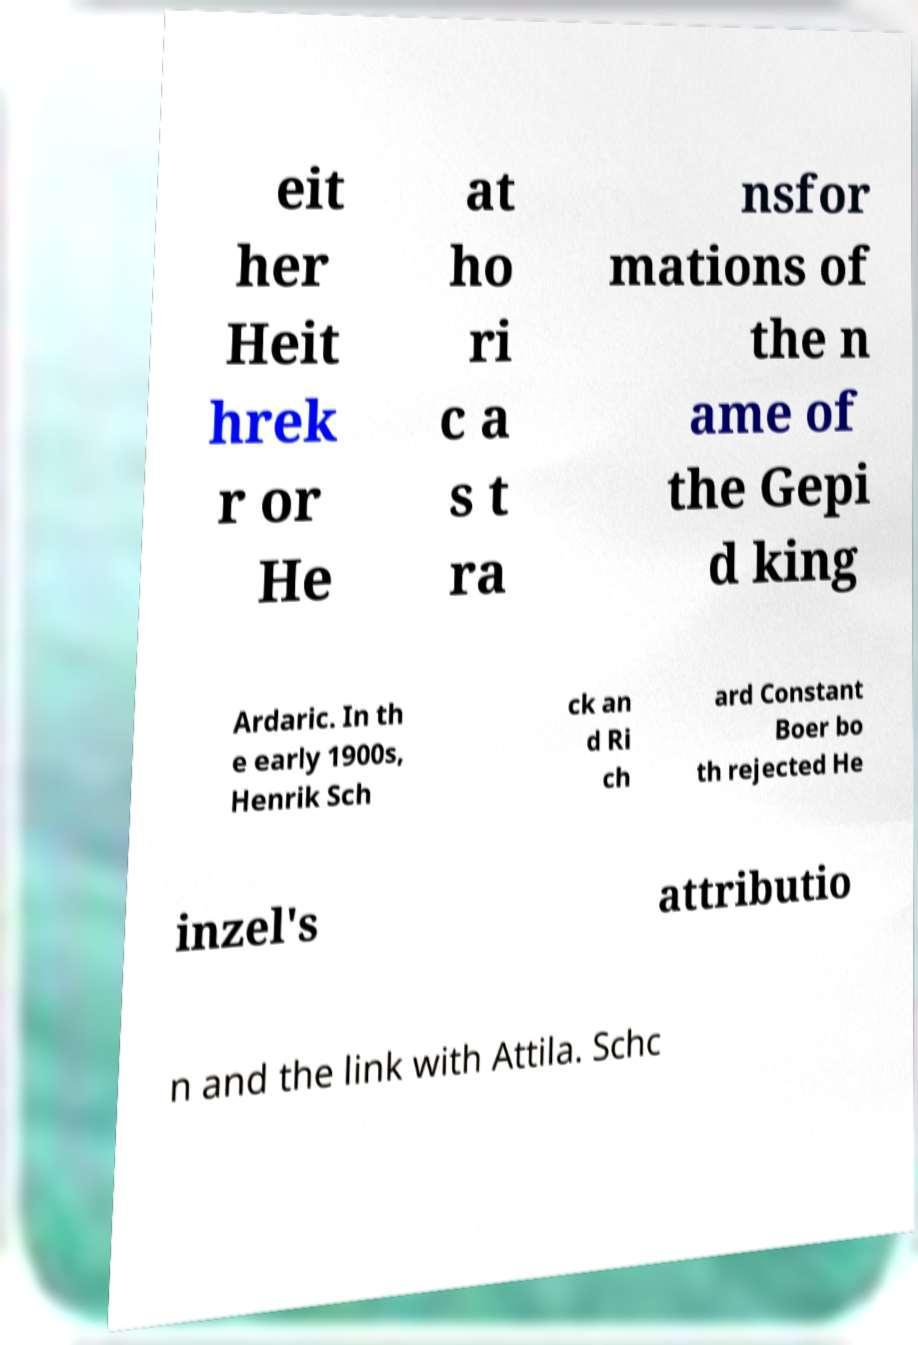For documentation purposes, I need the text within this image transcribed. Could you provide that? eit her Heit hrek r or He at ho ri c a s t ra nsfor mations of the n ame of the Gepi d king Ardaric. In th e early 1900s, Henrik Sch ck an d Ri ch ard Constant Boer bo th rejected He inzel's attributio n and the link with Attila. Schc 